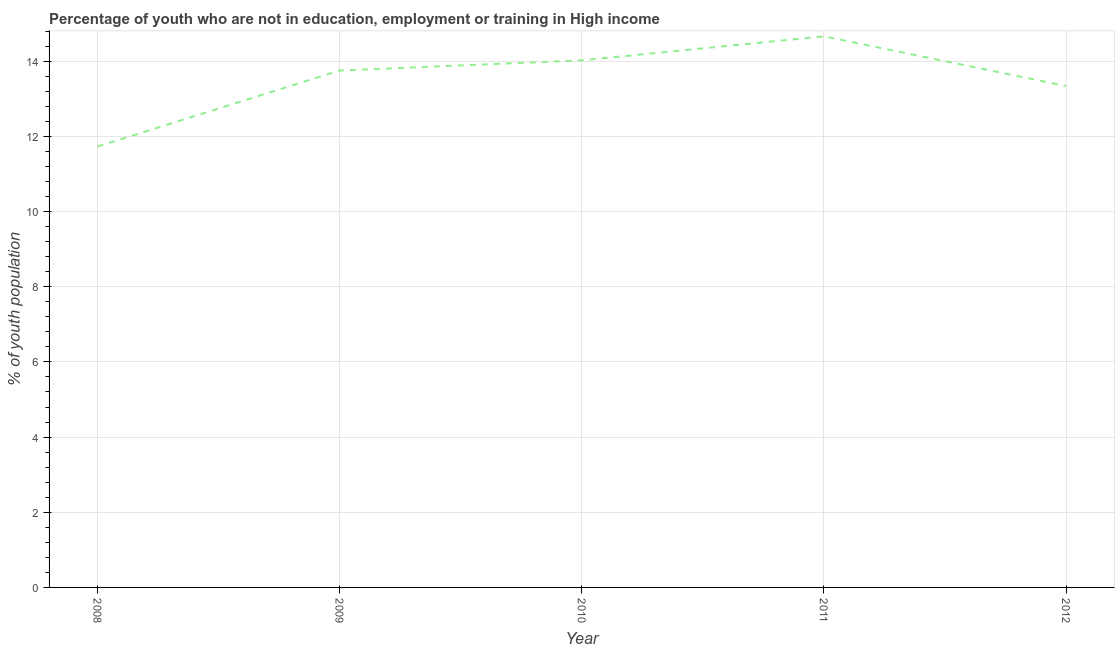What is the unemployed youth population in 2012?
Offer a very short reply. 13.34. Across all years, what is the maximum unemployed youth population?
Provide a short and direct response. 14.66. Across all years, what is the minimum unemployed youth population?
Make the answer very short. 11.73. In which year was the unemployed youth population maximum?
Provide a short and direct response. 2011. What is the sum of the unemployed youth population?
Your answer should be compact. 67.51. What is the difference between the unemployed youth population in 2009 and 2011?
Make the answer very short. -0.91. What is the average unemployed youth population per year?
Give a very brief answer. 13.5. What is the median unemployed youth population?
Your answer should be very brief. 13.75. In how many years, is the unemployed youth population greater than 10.8 %?
Give a very brief answer. 5. What is the ratio of the unemployed youth population in 2009 to that in 2010?
Your answer should be very brief. 0.98. Is the difference between the unemployed youth population in 2008 and 2010 greater than the difference between any two years?
Your answer should be very brief. No. What is the difference between the highest and the second highest unemployed youth population?
Ensure brevity in your answer.  0.64. Is the sum of the unemployed youth population in 2010 and 2012 greater than the maximum unemployed youth population across all years?
Make the answer very short. Yes. What is the difference between the highest and the lowest unemployed youth population?
Your answer should be compact. 2.93. Does the unemployed youth population monotonically increase over the years?
Your response must be concise. No. How many lines are there?
Give a very brief answer. 1. What is the difference between two consecutive major ticks on the Y-axis?
Offer a very short reply. 2. Are the values on the major ticks of Y-axis written in scientific E-notation?
Keep it short and to the point. No. What is the title of the graph?
Make the answer very short. Percentage of youth who are not in education, employment or training in High income. What is the label or title of the Y-axis?
Give a very brief answer. % of youth population. What is the % of youth population in 2008?
Your answer should be compact. 11.73. What is the % of youth population in 2009?
Provide a short and direct response. 13.75. What is the % of youth population in 2010?
Offer a very short reply. 14.02. What is the % of youth population of 2011?
Your answer should be very brief. 14.66. What is the % of youth population of 2012?
Ensure brevity in your answer.  13.34. What is the difference between the % of youth population in 2008 and 2009?
Provide a succinct answer. -2.02. What is the difference between the % of youth population in 2008 and 2010?
Ensure brevity in your answer.  -2.29. What is the difference between the % of youth population in 2008 and 2011?
Ensure brevity in your answer.  -2.93. What is the difference between the % of youth population in 2008 and 2012?
Offer a terse response. -1.61. What is the difference between the % of youth population in 2009 and 2010?
Offer a very short reply. -0.27. What is the difference between the % of youth population in 2009 and 2011?
Offer a terse response. -0.91. What is the difference between the % of youth population in 2009 and 2012?
Your answer should be compact. 0.41. What is the difference between the % of youth population in 2010 and 2011?
Offer a terse response. -0.64. What is the difference between the % of youth population in 2010 and 2012?
Give a very brief answer. 0.68. What is the difference between the % of youth population in 2011 and 2012?
Ensure brevity in your answer.  1.32. What is the ratio of the % of youth population in 2008 to that in 2009?
Offer a terse response. 0.85. What is the ratio of the % of youth population in 2008 to that in 2010?
Your response must be concise. 0.84. What is the ratio of the % of youth population in 2008 to that in 2011?
Give a very brief answer. 0.8. What is the ratio of the % of youth population in 2008 to that in 2012?
Provide a short and direct response. 0.88. What is the ratio of the % of youth population in 2009 to that in 2011?
Keep it short and to the point. 0.94. What is the ratio of the % of youth population in 2009 to that in 2012?
Offer a very short reply. 1.03. What is the ratio of the % of youth population in 2010 to that in 2011?
Make the answer very short. 0.96. What is the ratio of the % of youth population in 2010 to that in 2012?
Provide a short and direct response. 1.05. What is the ratio of the % of youth population in 2011 to that in 2012?
Provide a short and direct response. 1.1. 